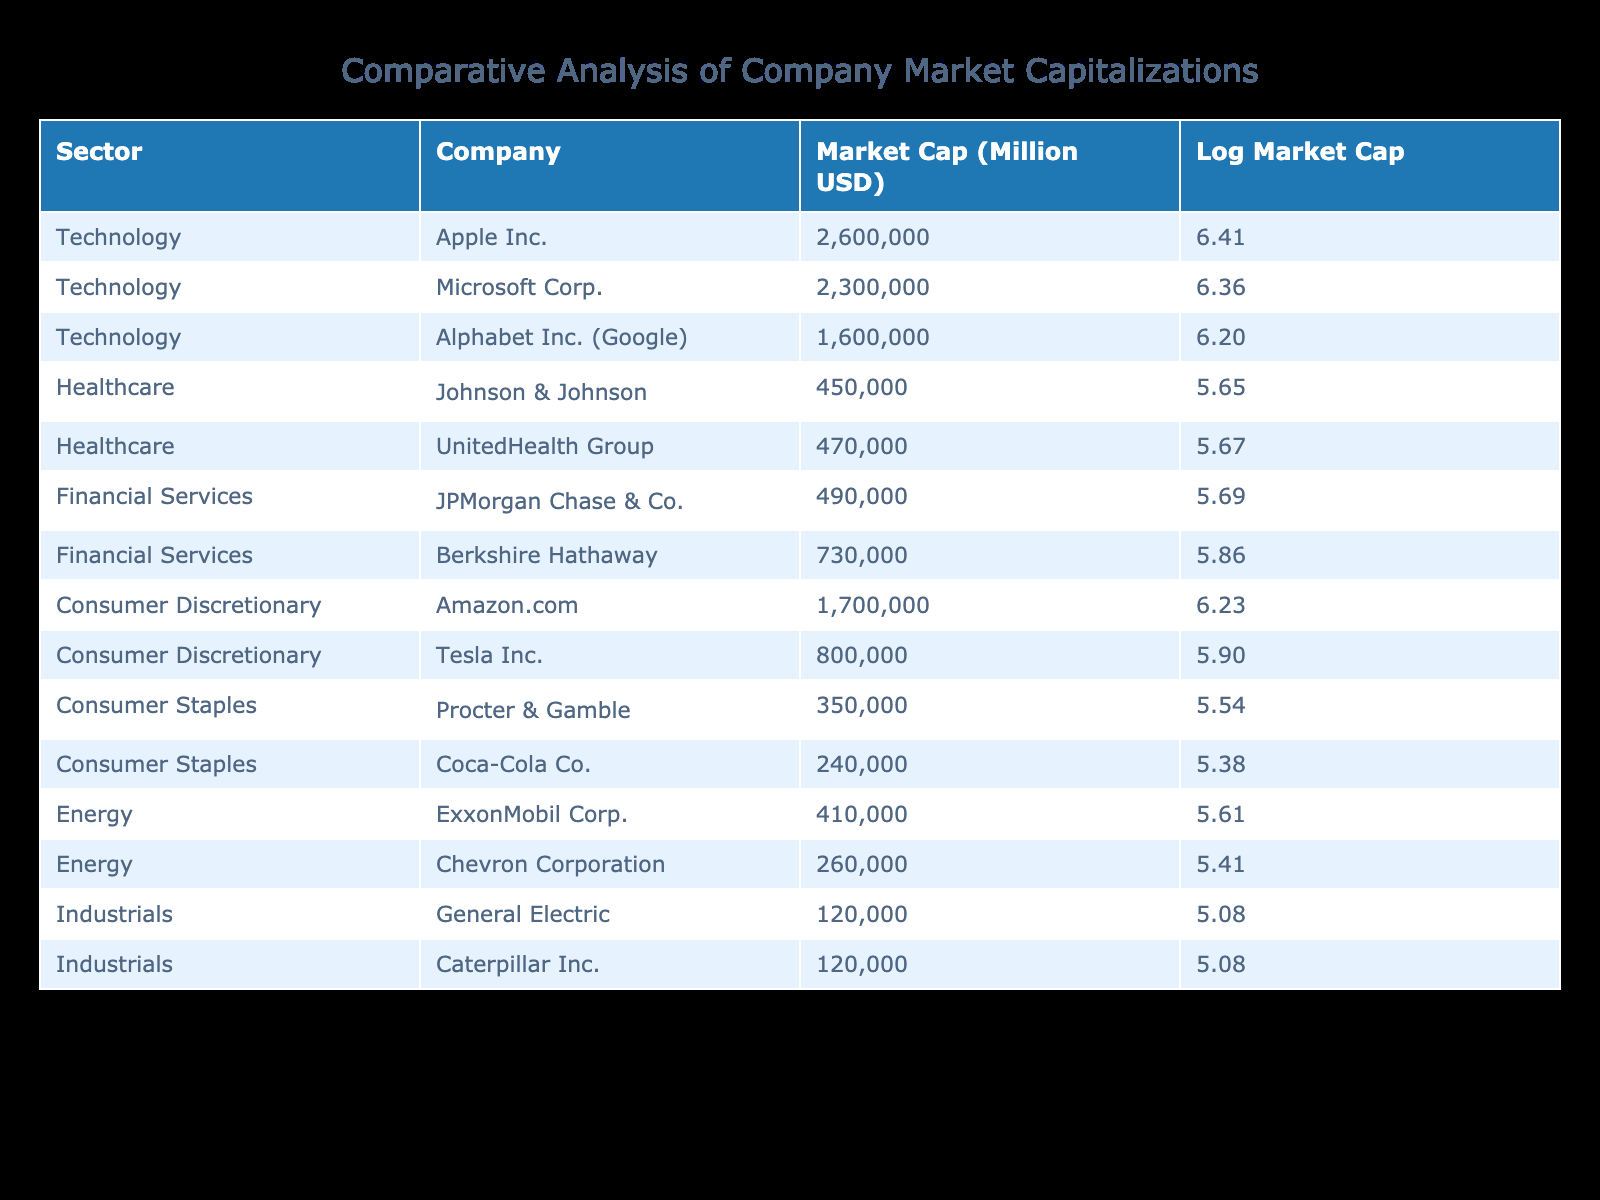What is the market capitalization of Apple Inc.? The table lists Apple Inc. under the Technology sector with a market capitalization of 2,600,000 million USD.
Answer: 2,600,000 million USD Which company has the highest market capitalization in the table? By comparing the market capitalizations provided, Apple Inc. has the highest at 2,600,000 million USD.
Answer: Apple Inc What is the average market capitalization of companies in the Healthcare sector? The market capitalizations for the Healthcare sector are 450,000 million USD (Johnson & Johnson) and 470,000 million USD (UnitedHealth Group). The average is (450,000 + 470,000) / 2 = 460,000 million USD.
Answer: 460,000 million USD Is Google’s market capitalization greater than that of Microsoft? The market capitalizations in the table indicate that Google has 1,600,000 million USD while Microsoft has 2,300,000 million USD. Since 1,600,000 is less than 2,300,000, the statement is false.
Answer: No What is the total market capitalization of all companies in the Energy sector? The Energy sector includes ExxonMobil Corp. with 410,000 million USD and Chevron Corporation with 260,000 million USD. Adding these gives 410,000 + 260,000 = 670,000 million USD.
Answer: 670,000 million USD Which sector has the lowest total market capitalization among the listed companies? The sectors and their total market capitalizations are: Healthcare (920,000 million USD), Financial Services (1,220,000 million USD), Consumer Discretionary (2,500,000 million USD), Consumer Staples (590,000 million USD), Energy (670,000 million USD), and Industrials (240,000 million USD). The sector with the lowest total is Industrials at 240,000 million USD.
Answer: Industrials What is the difference in market capitalization between the highest and lowest companies in the Consumer Discretionary sector? The companies in the Consumer Discretionary sector are Amazon.com with 1,700,000 million USD and Tesla Inc. with 800,000 million USD. The difference is 1,700,000 - 800,000 = 900,000 million USD.
Answer: 900,000 million USD True or False: Berkshire Hathaway is in the Technology sector. Berkshire Hathaway is listed under the Financial Services sector in the table, so this statement is false.
Answer: False What are the log market capitalization values for the company with the highest market capitalization and the one with the lowest? The highest market capitalization is Apple Inc. at 2,600,000 million USD, which has a log value of approximately 6.414. The lowest is General Electric and Caterpillar Inc., both at 120,000 million USD, with a log value of approximately 5.079.
Answer: 6.414 and 5.079 